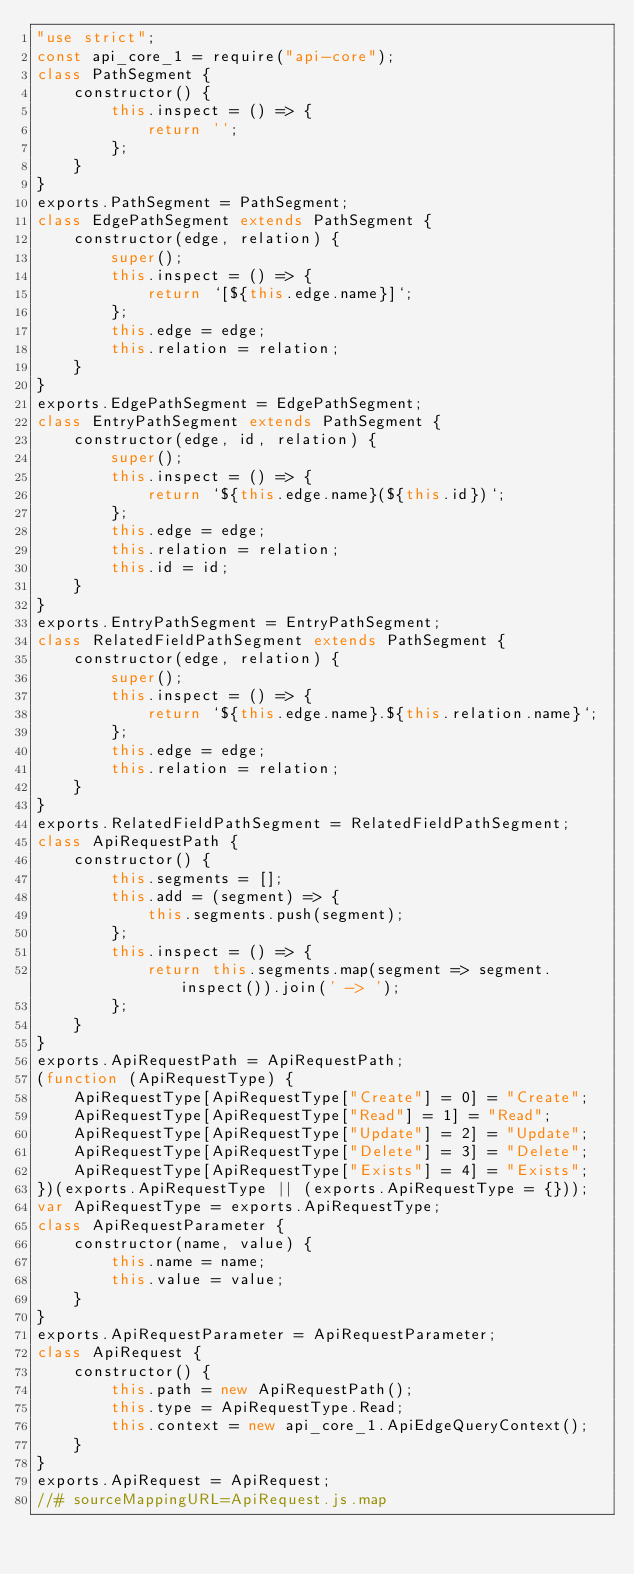<code> <loc_0><loc_0><loc_500><loc_500><_JavaScript_>"use strict";
const api_core_1 = require("api-core");
class PathSegment {
    constructor() {
        this.inspect = () => {
            return '';
        };
    }
}
exports.PathSegment = PathSegment;
class EdgePathSegment extends PathSegment {
    constructor(edge, relation) {
        super();
        this.inspect = () => {
            return `[${this.edge.name}]`;
        };
        this.edge = edge;
        this.relation = relation;
    }
}
exports.EdgePathSegment = EdgePathSegment;
class EntryPathSegment extends PathSegment {
    constructor(edge, id, relation) {
        super();
        this.inspect = () => {
            return `${this.edge.name}(${this.id})`;
        };
        this.edge = edge;
        this.relation = relation;
        this.id = id;
    }
}
exports.EntryPathSegment = EntryPathSegment;
class RelatedFieldPathSegment extends PathSegment {
    constructor(edge, relation) {
        super();
        this.inspect = () => {
            return `${this.edge.name}.${this.relation.name}`;
        };
        this.edge = edge;
        this.relation = relation;
    }
}
exports.RelatedFieldPathSegment = RelatedFieldPathSegment;
class ApiRequestPath {
    constructor() {
        this.segments = [];
        this.add = (segment) => {
            this.segments.push(segment);
        };
        this.inspect = () => {
            return this.segments.map(segment => segment.inspect()).join(' -> ');
        };
    }
}
exports.ApiRequestPath = ApiRequestPath;
(function (ApiRequestType) {
    ApiRequestType[ApiRequestType["Create"] = 0] = "Create";
    ApiRequestType[ApiRequestType["Read"] = 1] = "Read";
    ApiRequestType[ApiRequestType["Update"] = 2] = "Update";
    ApiRequestType[ApiRequestType["Delete"] = 3] = "Delete";
    ApiRequestType[ApiRequestType["Exists"] = 4] = "Exists";
})(exports.ApiRequestType || (exports.ApiRequestType = {}));
var ApiRequestType = exports.ApiRequestType;
class ApiRequestParameter {
    constructor(name, value) {
        this.name = name;
        this.value = value;
    }
}
exports.ApiRequestParameter = ApiRequestParameter;
class ApiRequest {
    constructor() {
        this.path = new ApiRequestPath();
        this.type = ApiRequestType.Read;
        this.context = new api_core_1.ApiEdgeQueryContext();
    }
}
exports.ApiRequest = ApiRequest;
//# sourceMappingURL=ApiRequest.js.map</code> 